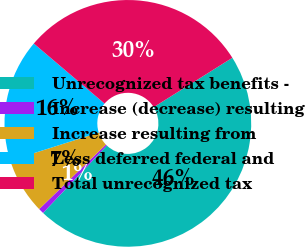Convert chart to OTSL. <chart><loc_0><loc_0><loc_500><loc_500><pie_chart><fcel>Unrecognized tax benefits -<fcel>Increase (decrease) resulting<fcel>Increase resulting from<fcel>Less deferred federal and<fcel>Total unrecognized tax<nl><fcel>45.98%<fcel>0.71%<fcel>7.34%<fcel>16.09%<fcel>29.88%<nl></chart> 